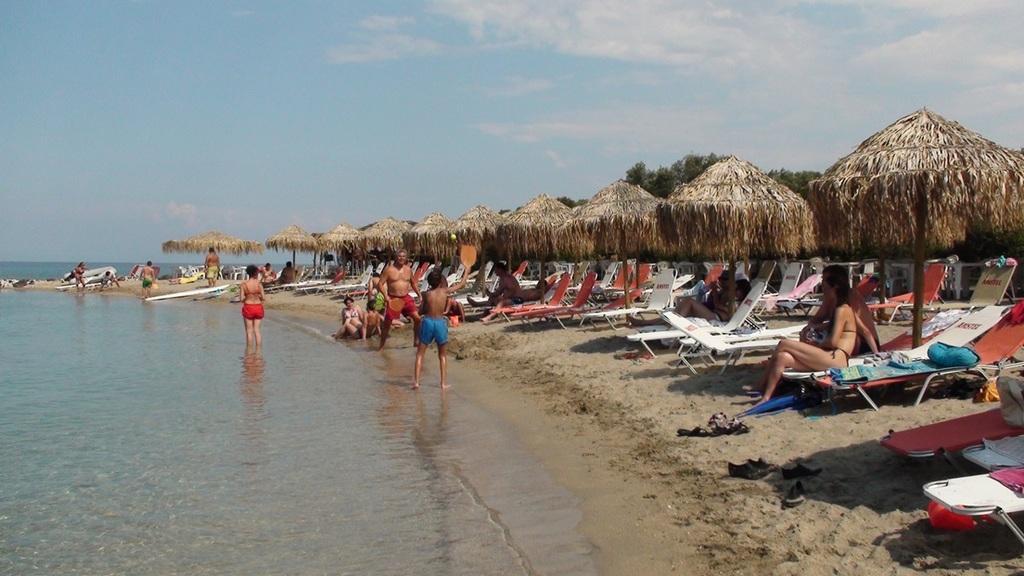Can you describe this image briefly? This image is clicked at a beach. To the left there is the water. To the right there is the ground. There is sand on the ground. There are table umbrellas and chairs on the ground. There are people sitting on the chairs. There are a few people on the shore. In the background there are trees. At the top there is the sky. 